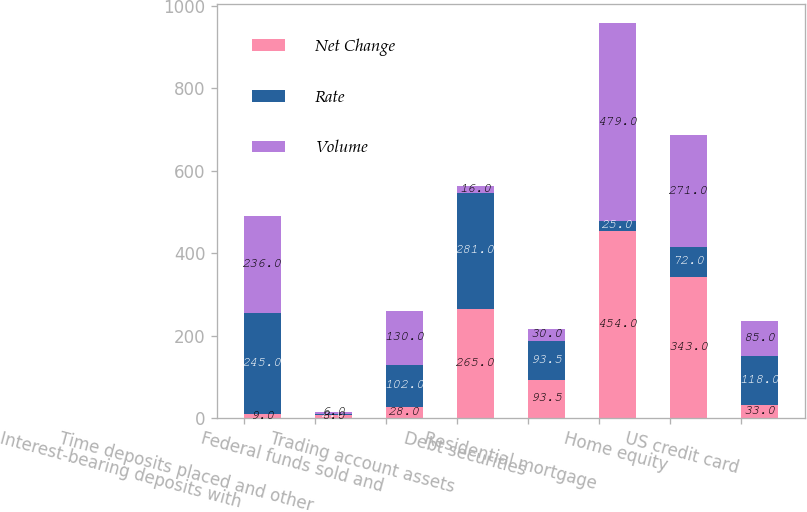Convert chart to OTSL. <chart><loc_0><loc_0><loc_500><loc_500><stacked_bar_chart><ecel><fcel>Interest-bearing deposits with<fcel>Time deposits placed and other<fcel>Federal funds sold and<fcel>Trading account assets<fcel>Debt securities<fcel>Residential mortgage<fcel>Home equity<fcel>US credit card<nl><fcel>Net Change<fcel>9<fcel>8<fcel>28<fcel>265<fcel>93.5<fcel>454<fcel>343<fcel>33<nl><fcel>Rate<fcel>245<fcel>2<fcel>102<fcel>281<fcel>93.5<fcel>25<fcel>72<fcel>118<nl><fcel>Volume<fcel>236<fcel>6<fcel>130<fcel>16<fcel>30<fcel>479<fcel>271<fcel>85<nl></chart> 